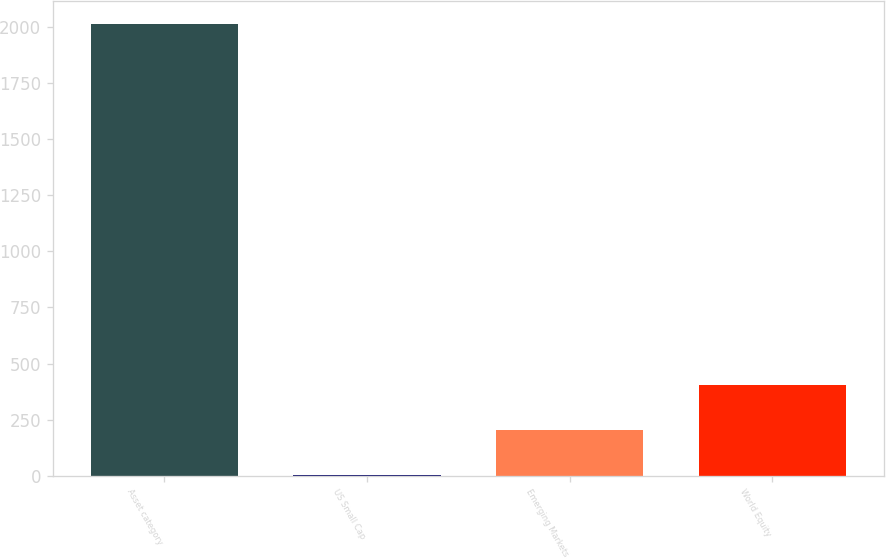Convert chart to OTSL. <chart><loc_0><loc_0><loc_500><loc_500><bar_chart><fcel>Asset category<fcel>US Small Cap<fcel>Emerging Markets<fcel>World Equity<nl><fcel>2015<fcel>4<fcel>205.1<fcel>406.2<nl></chart> 